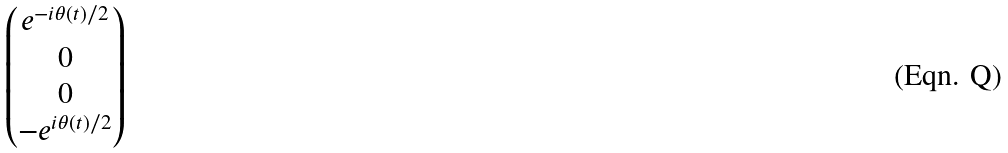Convert formula to latex. <formula><loc_0><loc_0><loc_500><loc_500>\begin{pmatrix} e ^ { - i \theta ( t ) / 2 } \\ 0 \\ 0 \\ - e ^ { i \theta ( t ) / 2 } \end{pmatrix}</formula> 